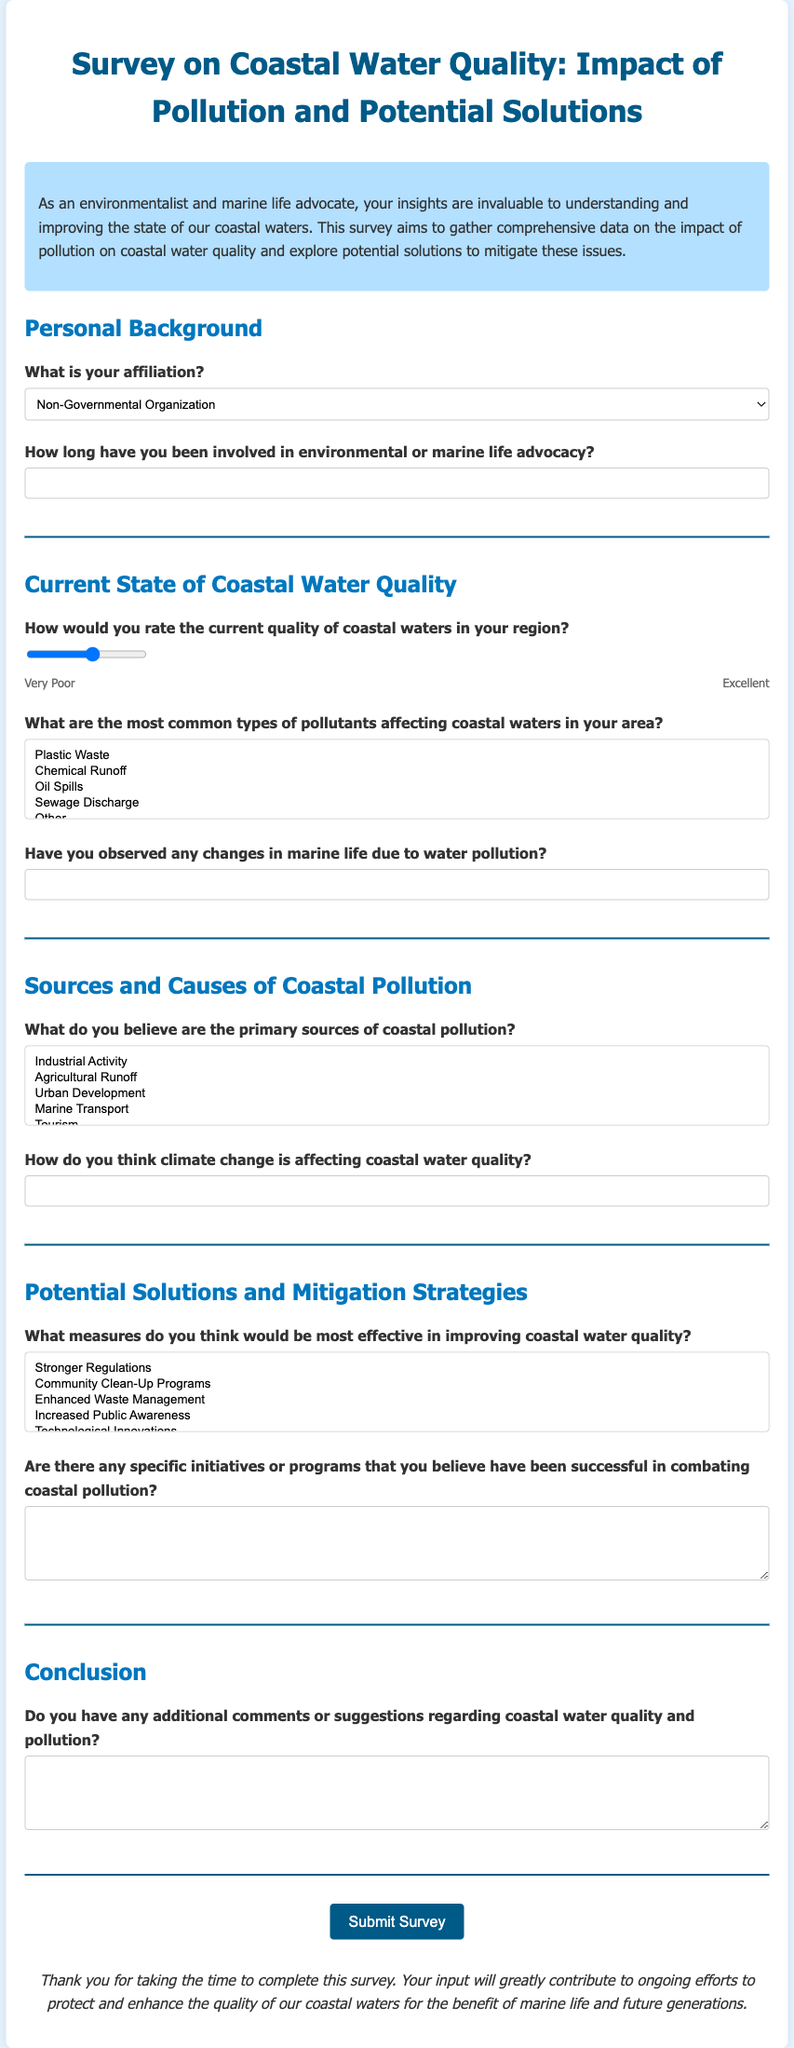What is the title of the survey? The title is stated at the top of the document and reflects the content of the survey.
Answer: Survey on Coastal Water Quality: Impact of Pollution and Potential Solutions What is the color of the introduction section? The introduction section is characterized by a specific background color, which is mentioned in the styling of the document.
Answer: #b3e0ff How many sections are in the survey? The number of sections can be counted by reviewing the layout of the document.
Answer: Five What type of organization affiliation can be selected? This is found in the options provided in the survey form for selection.
Answer: Non-Governmental Organization How would participants rate coastal water quality? This rating is indicated by a scale in the survey to assess the quality from poor to excellent.
Answer: 1 to 10 What measures can be selected to improve coastal water quality? The document lists different options for improving water quality as part of the survey questions.
Answer: Stronger Regulations What is the last question section titled in the survey? The title provided for the last section indicates what it covers.
Answer: Conclusion How are participants instructed to submit the survey? The submission method is described through a button action at the end of the document.
Answer: Click the Submit Survey button What is included in the thank-you note? The thank-you note concludes the survey and acknowledges the participants' contributions in a specific manner.
Answer: Contribution to ongoing efforts to protect and enhance coastal waters 